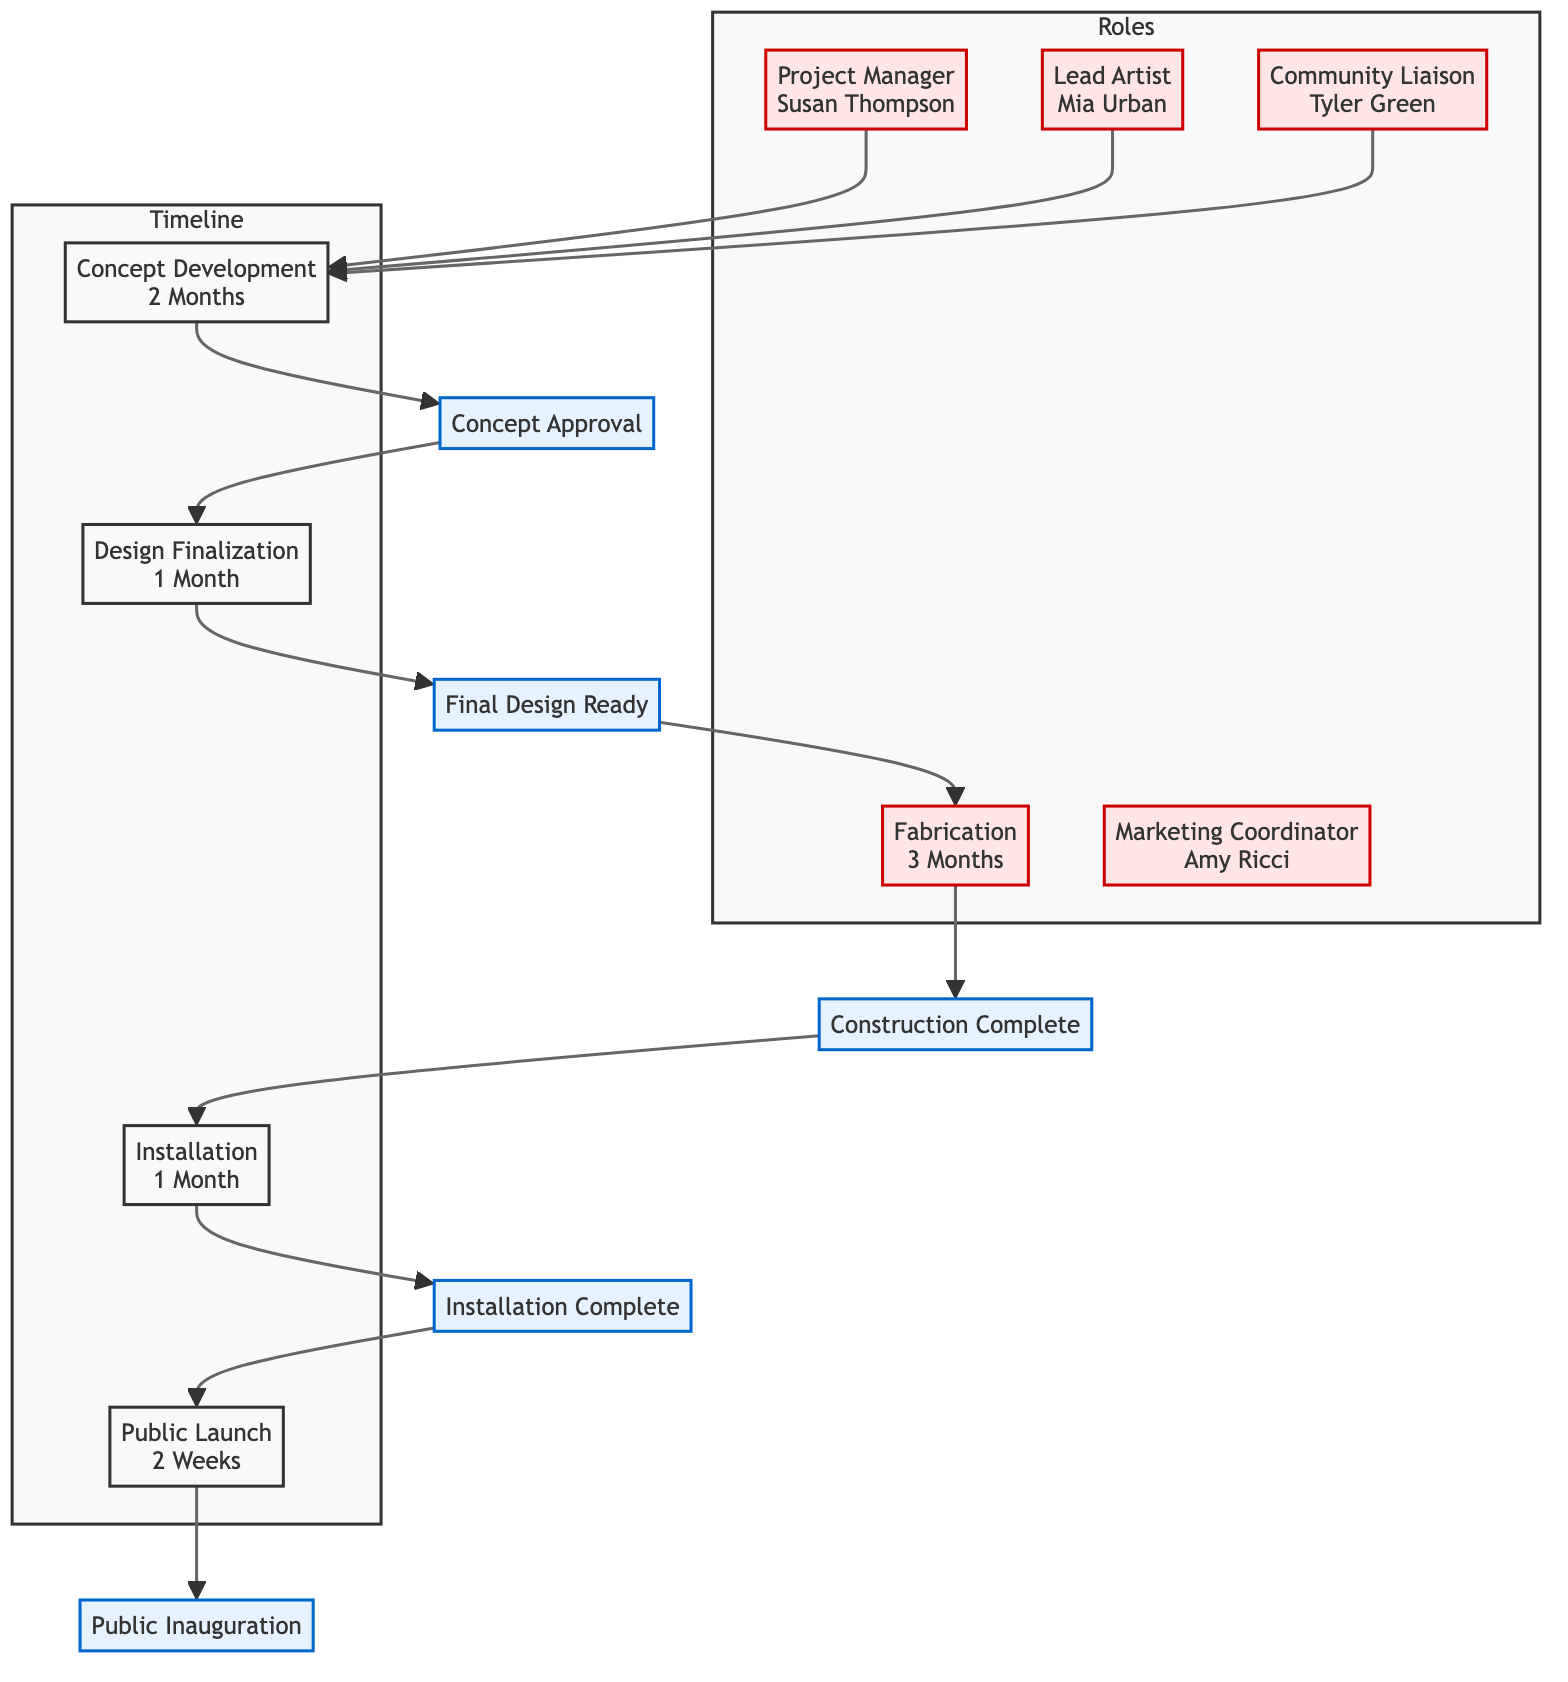What are the main roles involved in the project? The diagram shows five main roles: Project Manager, Lead Artist, Community Liaison, Fabricator, and Marketing Coordinator. Each role is represented as a node in the "Roles" section of the diagram.
Answer: Project Manager, Lead Artist, Community Liaison, Fabricator, Marketing Coordinator How many months is the Fabrication phase? The timeline node for Fabrication indicates a duration of 3 Months. This is a straightforward read from the timeline section of the diagram.
Answer: 3 Months Who is responsible for guiding the artistic direction? The Lead Artist role is responsible for guiding the artistic direction, as stated in their list of responsibilities in the diagram.
Answer: Mia Urban What is the milestone after the Concept Development phase? The milestone following the Concept Development phase is "Concept Approval." This is derived from the connections and labels in the timeline section of the diagram.
Answer: Concept Approval What task occurs right before the Public Launch? The task that occurs right before the Public Launch is "Assemble on-site," as indicated in the Installation phase of the timeline. This requires navigating through the preceding nodes in the timeline.
Answer: Assemble on-site How many weeks is the duration of the Public Launch? The duration of the Public Launch is given as 2 Weeks, as directly stated in the corresponding timeline node.
Answer: 2 Weeks Which role is primarily focused on community feedback? The Community Liaison is focused on gathering community feedback, as their responsibilities clearly emphasize connecting with local residents and ensuring involvement.
Answer: Community Liaison What action is taken during the Design Finalization phase? During the Design Finalization phase, the task being performed is "Get necessary approvals," which is part of the tasks listed under that specific phase in the timeline.
Answer: Get necessary approvals What is the final milestone in the timeline? The final milestone in the timeline is "Public Inauguration," which is the last milestone connected to the Public Launch phase in the sequence of the project timeline.
Answer: Public Inauguration 